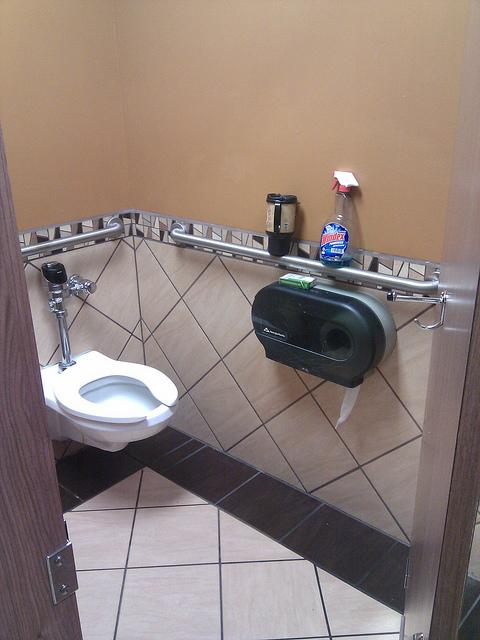Is this a home bathroom?
Quick response, please. No. Does the toilet flush automatically?
Write a very short answer. Yes. The toilet does?
Short answer required. Yes. 